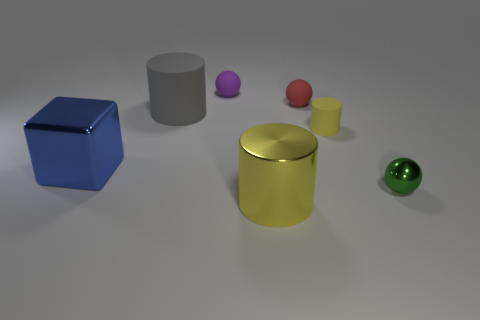If we look at the arrangement of the objects, what can you infer about the light source? The light source appears to be coming from the top-left direction since the shadows of the objects are cast towards the bottom-right. This suggests an angled, rather than a directly overhead, light source. 